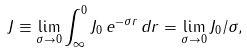<formula> <loc_0><loc_0><loc_500><loc_500>J \equiv \lim _ { \sigma \rightarrow 0 } \int _ { \infty } ^ { 0 } J _ { 0 } \, e ^ { - \sigma r } \, d r = \lim _ { \sigma \rightarrow 0 } J _ { 0 } / \sigma ,</formula> 